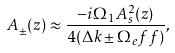Convert formula to latex. <formula><loc_0><loc_0><loc_500><loc_500>A _ { \pm } ( z ) \approx \frac { - i \Omega _ { 1 } A _ { s } ^ { 2 } ( z ) } { 4 ( \Delta k \pm \Omega _ { e } f f ) } ,</formula> 